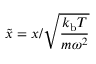<formula> <loc_0><loc_0><loc_500><loc_500>\tilde { x } = x / \sqrt { \frac { k _ { b } T } { m \omega ^ { 2 } } }</formula> 